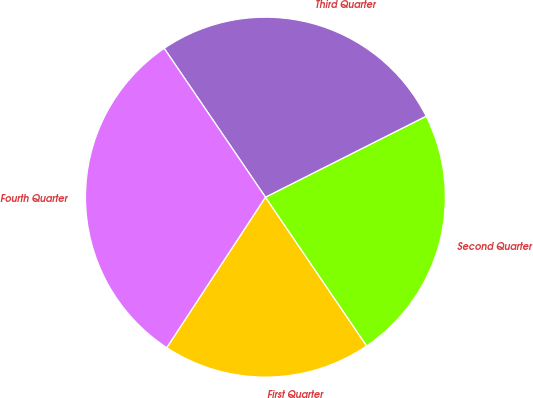Convert chart to OTSL. <chart><loc_0><loc_0><loc_500><loc_500><pie_chart><fcel>First Quarter<fcel>Second Quarter<fcel>Third Quarter<fcel>Fourth Quarter<nl><fcel>18.75%<fcel>22.92%<fcel>27.08%<fcel>31.25%<nl></chart> 